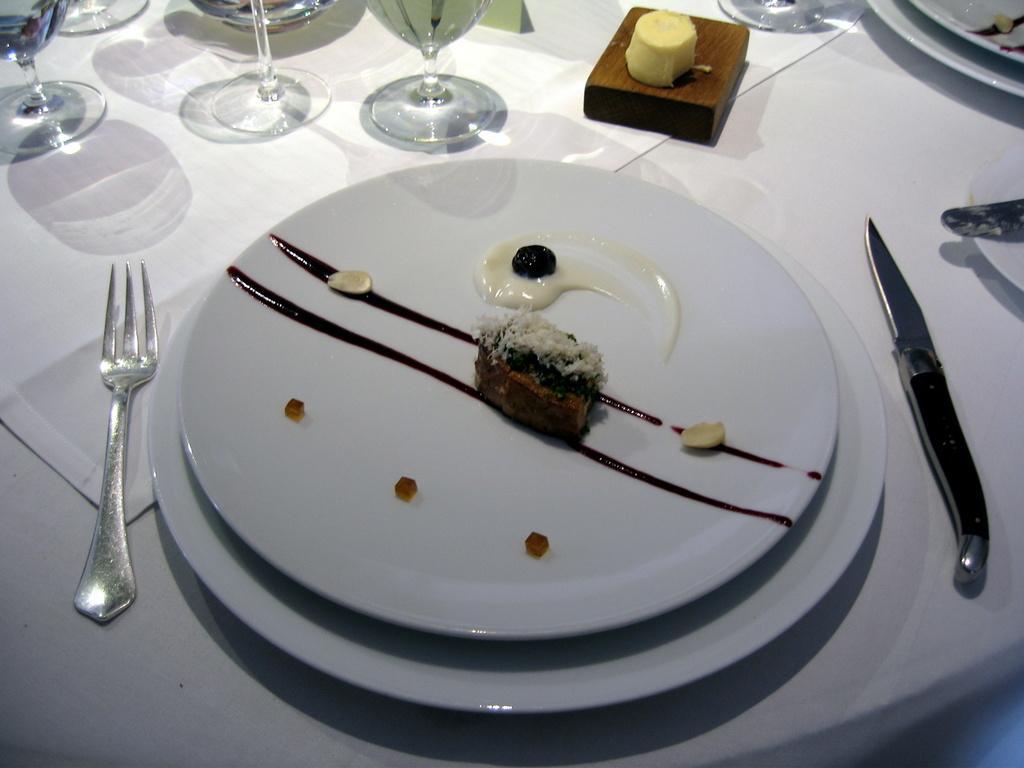Could you give a brief overview of what you see in this image? This is the table covered with white cloth. I can see glasses,fork,knife,plates and few other objects on the table. This looks like a desert on the plate. 